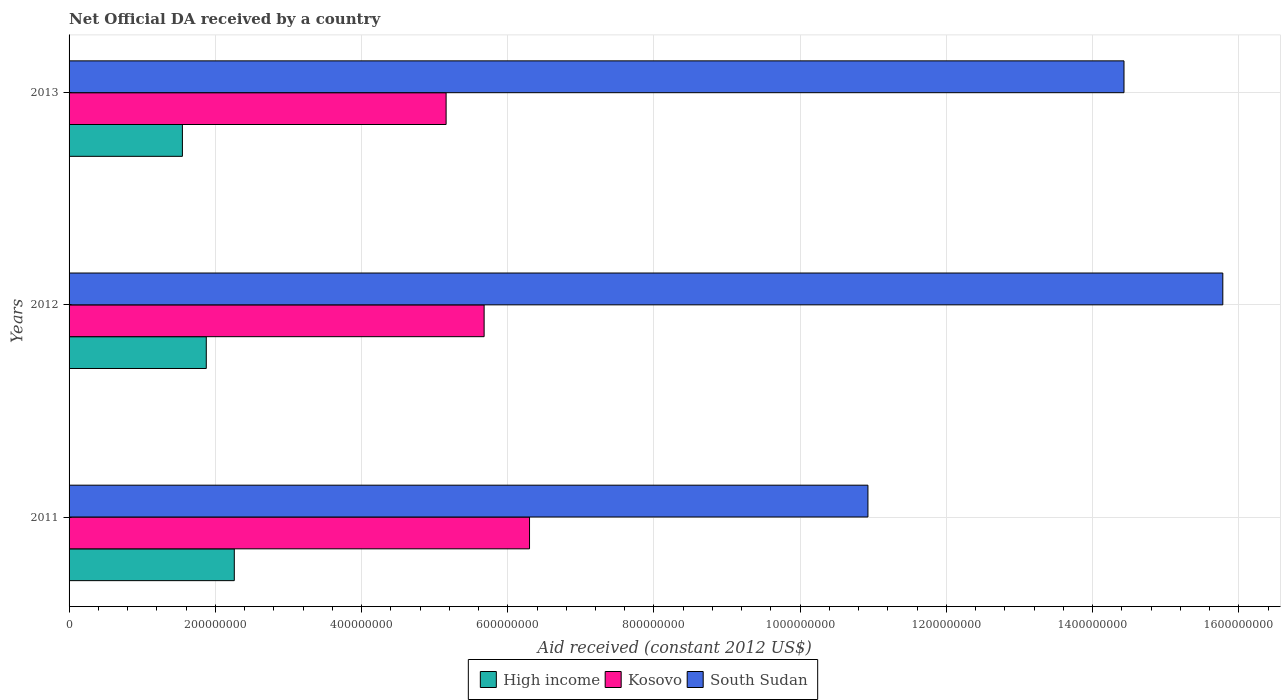How many different coloured bars are there?
Keep it short and to the point. 3. Are the number of bars per tick equal to the number of legend labels?
Give a very brief answer. Yes. How many bars are there on the 1st tick from the top?
Keep it short and to the point. 3. How many bars are there on the 3rd tick from the bottom?
Your answer should be compact. 3. What is the net official development assistance aid received in Kosovo in 2011?
Make the answer very short. 6.30e+08. Across all years, what is the maximum net official development assistance aid received in South Sudan?
Give a very brief answer. 1.58e+09. Across all years, what is the minimum net official development assistance aid received in South Sudan?
Ensure brevity in your answer.  1.09e+09. In which year was the net official development assistance aid received in High income minimum?
Ensure brevity in your answer.  2013. What is the total net official development assistance aid received in Kosovo in the graph?
Offer a very short reply. 1.71e+09. What is the difference between the net official development assistance aid received in Kosovo in 2012 and that in 2013?
Make the answer very short. 5.20e+07. What is the difference between the net official development assistance aid received in High income in 2013 and the net official development assistance aid received in Kosovo in 2012?
Give a very brief answer. -4.13e+08. What is the average net official development assistance aid received in South Sudan per year?
Make the answer very short. 1.37e+09. In the year 2013, what is the difference between the net official development assistance aid received in Kosovo and net official development assistance aid received in South Sudan?
Provide a succinct answer. -9.27e+08. What is the ratio of the net official development assistance aid received in High income in 2012 to that in 2013?
Offer a very short reply. 1.21. Is the difference between the net official development assistance aid received in Kosovo in 2012 and 2013 greater than the difference between the net official development assistance aid received in South Sudan in 2012 and 2013?
Provide a succinct answer. No. What is the difference between the highest and the second highest net official development assistance aid received in High income?
Offer a terse response. 3.83e+07. What is the difference between the highest and the lowest net official development assistance aid received in Kosovo?
Offer a very short reply. 1.14e+08. Is the sum of the net official development assistance aid received in South Sudan in 2011 and 2012 greater than the maximum net official development assistance aid received in Kosovo across all years?
Provide a short and direct response. Yes. What does the 3rd bar from the top in 2013 represents?
Offer a terse response. High income. What does the 2nd bar from the bottom in 2012 represents?
Provide a succinct answer. Kosovo. Is it the case that in every year, the sum of the net official development assistance aid received in Kosovo and net official development assistance aid received in High income is greater than the net official development assistance aid received in South Sudan?
Your response must be concise. No. How many years are there in the graph?
Keep it short and to the point. 3. What is the difference between two consecutive major ticks on the X-axis?
Provide a succinct answer. 2.00e+08. Are the values on the major ticks of X-axis written in scientific E-notation?
Keep it short and to the point. No. Does the graph contain grids?
Offer a very short reply. Yes. How are the legend labels stacked?
Your answer should be compact. Horizontal. What is the title of the graph?
Offer a terse response. Net Official DA received by a country. What is the label or title of the X-axis?
Ensure brevity in your answer.  Aid received (constant 2012 US$). What is the Aid received (constant 2012 US$) of High income in 2011?
Offer a very short reply. 2.26e+08. What is the Aid received (constant 2012 US$) of Kosovo in 2011?
Give a very brief answer. 6.30e+08. What is the Aid received (constant 2012 US$) of South Sudan in 2011?
Your answer should be very brief. 1.09e+09. What is the Aid received (constant 2012 US$) in High income in 2012?
Ensure brevity in your answer.  1.88e+08. What is the Aid received (constant 2012 US$) in Kosovo in 2012?
Your response must be concise. 5.68e+08. What is the Aid received (constant 2012 US$) of South Sudan in 2012?
Provide a succinct answer. 1.58e+09. What is the Aid received (constant 2012 US$) of High income in 2013?
Offer a very short reply. 1.55e+08. What is the Aid received (constant 2012 US$) in Kosovo in 2013?
Offer a terse response. 5.16e+08. What is the Aid received (constant 2012 US$) in South Sudan in 2013?
Give a very brief answer. 1.44e+09. Across all years, what is the maximum Aid received (constant 2012 US$) of High income?
Your response must be concise. 2.26e+08. Across all years, what is the maximum Aid received (constant 2012 US$) in Kosovo?
Your answer should be compact. 6.30e+08. Across all years, what is the maximum Aid received (constant 2012 US$) of South Sudan?
Provide a short and direct response. 1.58e+09. Across all years, what is the minimum Aid received (constant 2012 US$) of High income?
Your answer should be very brief. 1.55e+08. Across all years, what is the minimum Aid received (constant 2012 US$) of Kosovo?
Offer a terse response. 5.16e+08. Across all years, what is the minimum Aid received (constant 2012 US$) of South Sudan?
Provide a short and direct response. 1.09e+09. What is the total Aid received (constant 2012 US$) of High income in the graph?
Provide a short and direct response. 5.69e+08. What is the total Aid received (constant 2012 US$) of Kosovo in the graph?
Provide a short and direct response. 1.71e+09. What is the total Aid received (constant 2012 US$) of South Sudan in the graph?
Provide a short and direct response. 4.11e+09. What is the difference between the Aid received (constant 2012 US$) of High income in 2011 and that in 2012?
Keep it short and to the point. 3.83e+07. What is the difference between the Aid received (constant 2012 US$) of Kosovo in 2011 and that in 2012?
Your answer should be compact. 6.21e+07. What is the difference between the Aid received (constant 2012 US$) of South Sudan in 2011 and that in 2012?
Your response must be concise. -4.85e+08. What is the difference between the Aid received (constant 2012 US$) in High income in 2011 and that in 2013?
Provide a short and direct response. 7.10e+07. What is the difference between the Aid received (constant 2012 US$) in Kosovo in 2011 and that in 2013?
Your answer should be compact. 1.14e+08. What is the difference between the Aid received (constant 2012 US$) in South Sudan in 2011 and that in 2013?
Give a very brief answer. -3.50e+08. What is the difference between the Aid received (constant 2012 US$) of High income in 2012 and that in 2013?
Ensure brevity in your answer.  3.26e+07. What is the difference between the Aid received (constant 2012 US$) in Kosovo in 2012 and that in 2013?
Make the answer very short. 5.20e+07. What is the difference between the Aid received (constant 2012 US$) of South Sudan in 2012 and that in 2013?
Your answer should be compact. 1.35e+08. What is the difference between the Aid received (constant 2012 US$) in High income in 2011 and the Aid received (constant 2012 US$) in Kosovo in 2012?
Your answer should be very brief. -3.42e+08. What is the difference between the Aid received (constant 2012 US$) in High income in 2011 and the Aid received (constant 2012 US$) in South Sudan in 2012?
Provide a succinct answer. -1.35e+09. What is the difference between the Aid received (constant 2012 US$) of Kosovo in 2011 and the Aid received (constant 2012 US$) of South Sudan in 2012?
Keep it short and to the point. -9.48e+08. What is the difference between the Aid received (constant 2012 US$) in High income in 2011 and the Aid received (constant 2012 US$) in Kosovo in 2013?
Make the answer very short. -2.90e+08. What is the difference between the Aid received (constant 2012 US$) in High income in 2011 and the Aid received (constant 2012 US$) in South Sudan in 2013?
Your answer should be compact. -1.22e+09. What is the difference between the Aid received (constant 2012 US$) in Kosovo in 2011 and the Aid received (constant 2012 US$) in South Sudan in 2013?
Provide a short and direct response. -8.13e+08. What is the difference between the Aid received (constant 2012 US$) in High income in 2012 and the Aid received (constant 2012 US$) in Kosovo in 2013?
Offer a terse response. -3.28e+08. What is the difference between the Aid received (constant 2012 US$) in High income in 2012 and the Aid received (constant 2012 US$) in South Sudan in 2013?
Ensure brevity in your answer.  -1.26e+09. What is the difference between the Aid received (constant 2012 US$) in Kosovo in 2012 and the Aid received (constant 2012 US$) in South Sudan in 2013?
Offer a very short reply. -8.75e+08. What is the average Aid received (constant 2012 US$) of High income per year?
Provide a short and direct response. 1.90e+08. What is the average Aid received (constant 2012 US$) of Kosovo per year?
Offer a very short reply. 5.71e+08. What is the average Aid received (constant 2012 US$) of South Sudan per year?
Your response must be concise. 1.37e+09. In the year 2011, what is the difference between the Aid received (constant 2012 US$) in High income and Aid received (constant 2012 US$) in Kosovo?
Give a very brief answer. -4.04e+08. In the year 2011, what is the difference between the Aid received (constant 2012 US$) of High income and Aid received (constant 2012 US$) of South Sudan?
Your answer should be very brief. -8.67e+08. In the year 2011, what is the difference between the Aid received (constant 2012 US$) in Kosovo and Aid received (constant 2012 US$) in South Sudan?
Provide a succinct answer. -4.63e+08. In the year 2012, what is the difference between the Aid received (constant 2012 US$) of High income and Aid received (constant 2012 US$) of Kosovo?
Offer a very short reply. -3.80e+08. In the year 2012, what is the difference between the Aid received (constant 2012 US$) of High income and Aid received (constant 2012 US$) of South Sudan?
Your answer should be compact. -1.39e+09. In the year 2012, what is the difference between the Aid received (constant 2012 US$) in Kosovo and Aid received (constant 2012 US$) in South Sudan?
Keep it short and to the point. -1.01e+09. In the year 2013, what is the difference between the Aid received (constant 2012 US$) in High income and Aid received (constant 2012 US$) in Kosovo?
Your response must be concise. -3.61e+08. In the year 2013, what is the difference between the Aid received (constant 2012 US$) of High income and Aid received (constant 2012 US$) of South Sudan?
Your answer should be compact. -1.29e+09. In the year 2013, what is the difference between the Aid received (constant 2012 US$) in Kosovo and Aid received (constant 2012 US$) in South Sudan?
Offer a very short reply. -9.27e+08. What is the ratio of the Aid received (constant 2012 US$) in High income in 2011 to that in 2012?
Your answer should be compact. 1.2. What is the ratio of the Aid received (constant 2012 US$) of Kosovo in 2011 to that in 2012?
Provide a succinct answer. 1.11. What is the ratio of the Aid received (constant 2012 US$) in South Sudan in 2011 to that in 2012?
Keep it short and to the point. 0.69. What is the ratio of the Aid received (constant 2012 US$) of High income in 2011 to that in 2013?
Provide a short and direct response. 1.46. What is the ratio of the Aid received (constant 2012 US$) in Kosovo in 2011 to that in 2013?
Offer a terse response. 1.22. What is the ratio of the Aid received (constant 2012 US$) in South Sudan in 2011 to that in 2013?
Ensure brevity in your answer.  0.76. What is the ratio of the Aid received (constant 2012 US$) in High income in 2012 to that in 2013?
Provide a short and direct response. 1.21. What is the ratio of the Aid received (constant 2012 US$) in Kosovo in 2012 to that in 2013?
Offer a very short reply. 1.1. What is the ratio of the Aid received (constant 2012 US$) of South Sudan in 2012 to that in 2013?
Offer a terse response. 1.09. What is the difference between the highest and the second highest Aid received (constant 2012 US$) in High income?
Your answer should be compact. 3.83e+07. What is the difference between the highest and the second highest Aid received (constant 2012 US$) in Kosovo?
Your answer should be compact. 6.21e+07. What is the difference between the highest and the second highest Aid received (constant 2012 US$) of South Sudan?
Ensure brevity in your answer.  1.35e+08. What is the difference between the highest and the lowest Aid received (constant 2012 US$) of High income?
Your answer should be compact. 7.10e+07. What is the difference between the highest and the lowest Aid received (constant 2012 US$) of Kosovo?
Your answer should be very brief. 1.14e+08. What is the difference between the highest and the lowest Aid received (constant 2012 US$) in South Sudan?
Give a very brief answer. 4.85e+08. 